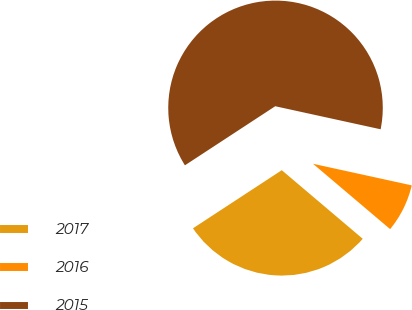Convert chart to OTSL. <chart><loc_0><loc_0><loc_500><loc_500><pie_chart><fcel>2017<fcel>2016<fcel>2015<nl><fcel>29.59%<fcel>7.76%<fcel>62.65%<nl></chart> 